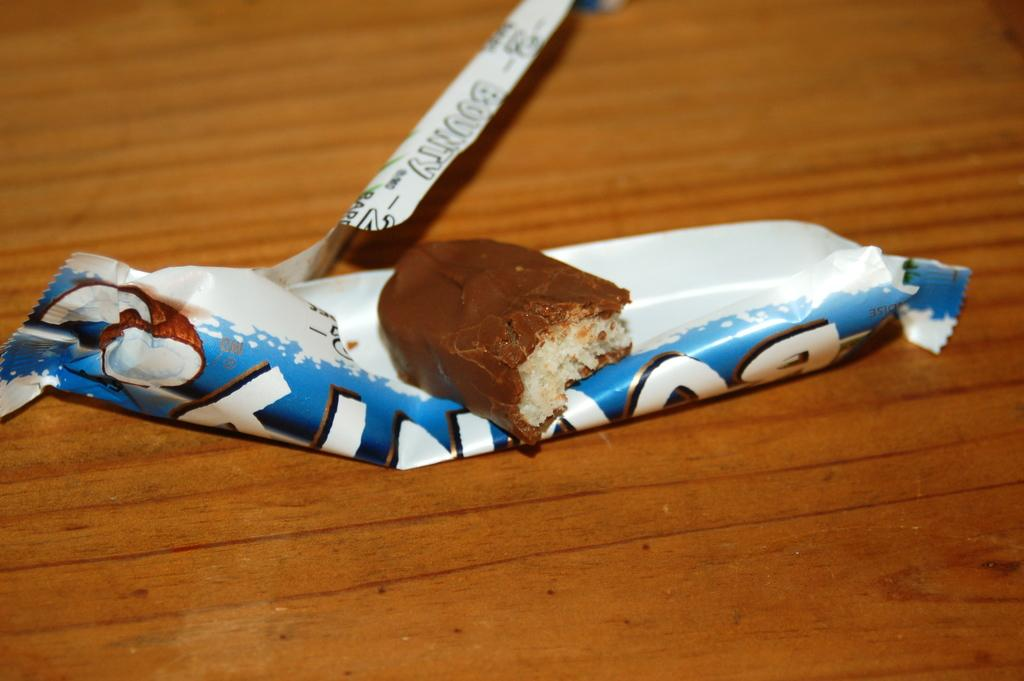What is the main subject of the image? The main subject of the image is a piece of chocolate. What is the piece of chocolate placed on? The piece of chocolate is on a chocolate cover. Where is the chocolate cover located? The chocolate cover is on a table. What is the annual income of the person who made the chocolate stew in the image? There is no chocolate stew present in the image, and therefore no information about the income of the person who made it. 